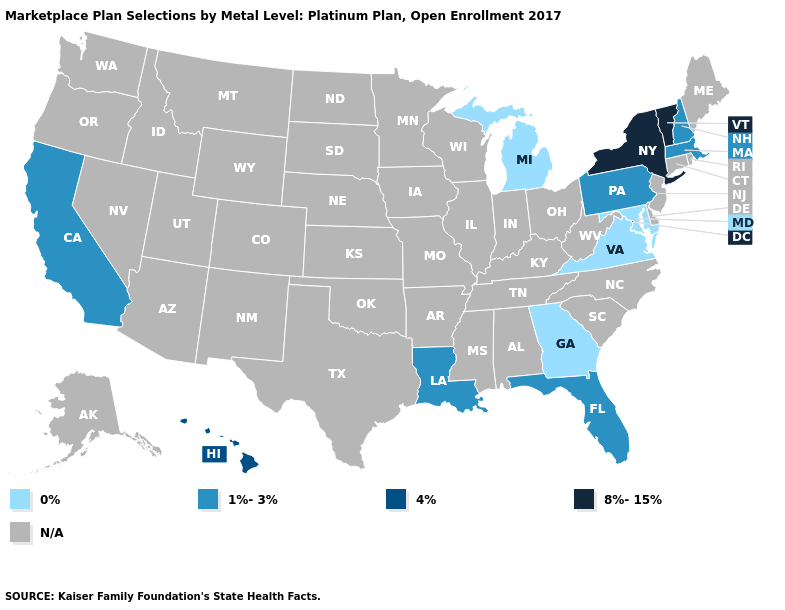Name the states that have a value in the range 8%-15%?
Quick response, please. New York, Vermont. Among the states that border Ohio , which have the lowest value?
Quick response, please. Michigan. What is the value of New Jersey?
Short answer required. N/A. What is the value of Wisconsin?
Write a very short answer. N/A. Name the states that have a value in the range 0%?
Short answer required. Georgia, Maryland, Michigan, Virginia. What is the value of Michigan?
Short answer required. 0%. What is the value of Colorado?
Write a very short answer. N/A. Does the map have missing data?
Short answer required. Yes. What is the value of Illinois?
Give a very brief answer. N/A. Name the states that have a value in the range 8%-15%?
Keep it brief. New York, Vermont. Is the legend a continuous bar?
Concise answer only. No. Name the states that have a value in the range 4%?
Give a very brief answer. Hawaii. 